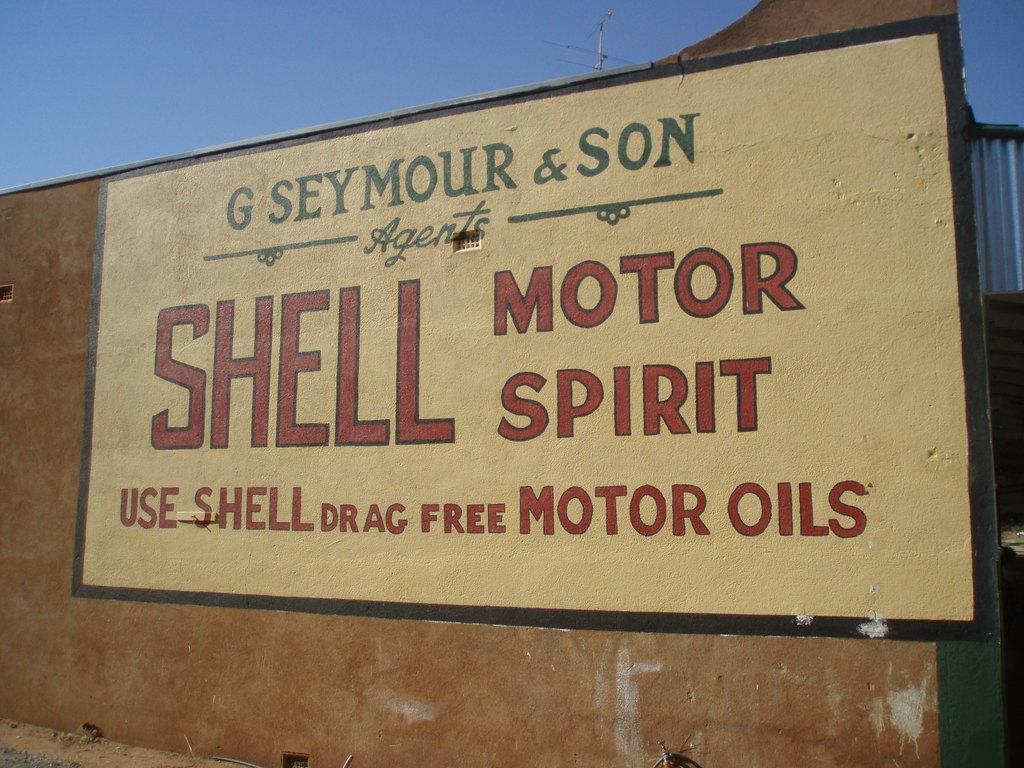What products does the sign say they give for free?
Make the answer very short. Motor oils. Who owns the shell?
Make the answer very short. G seymour & son. 